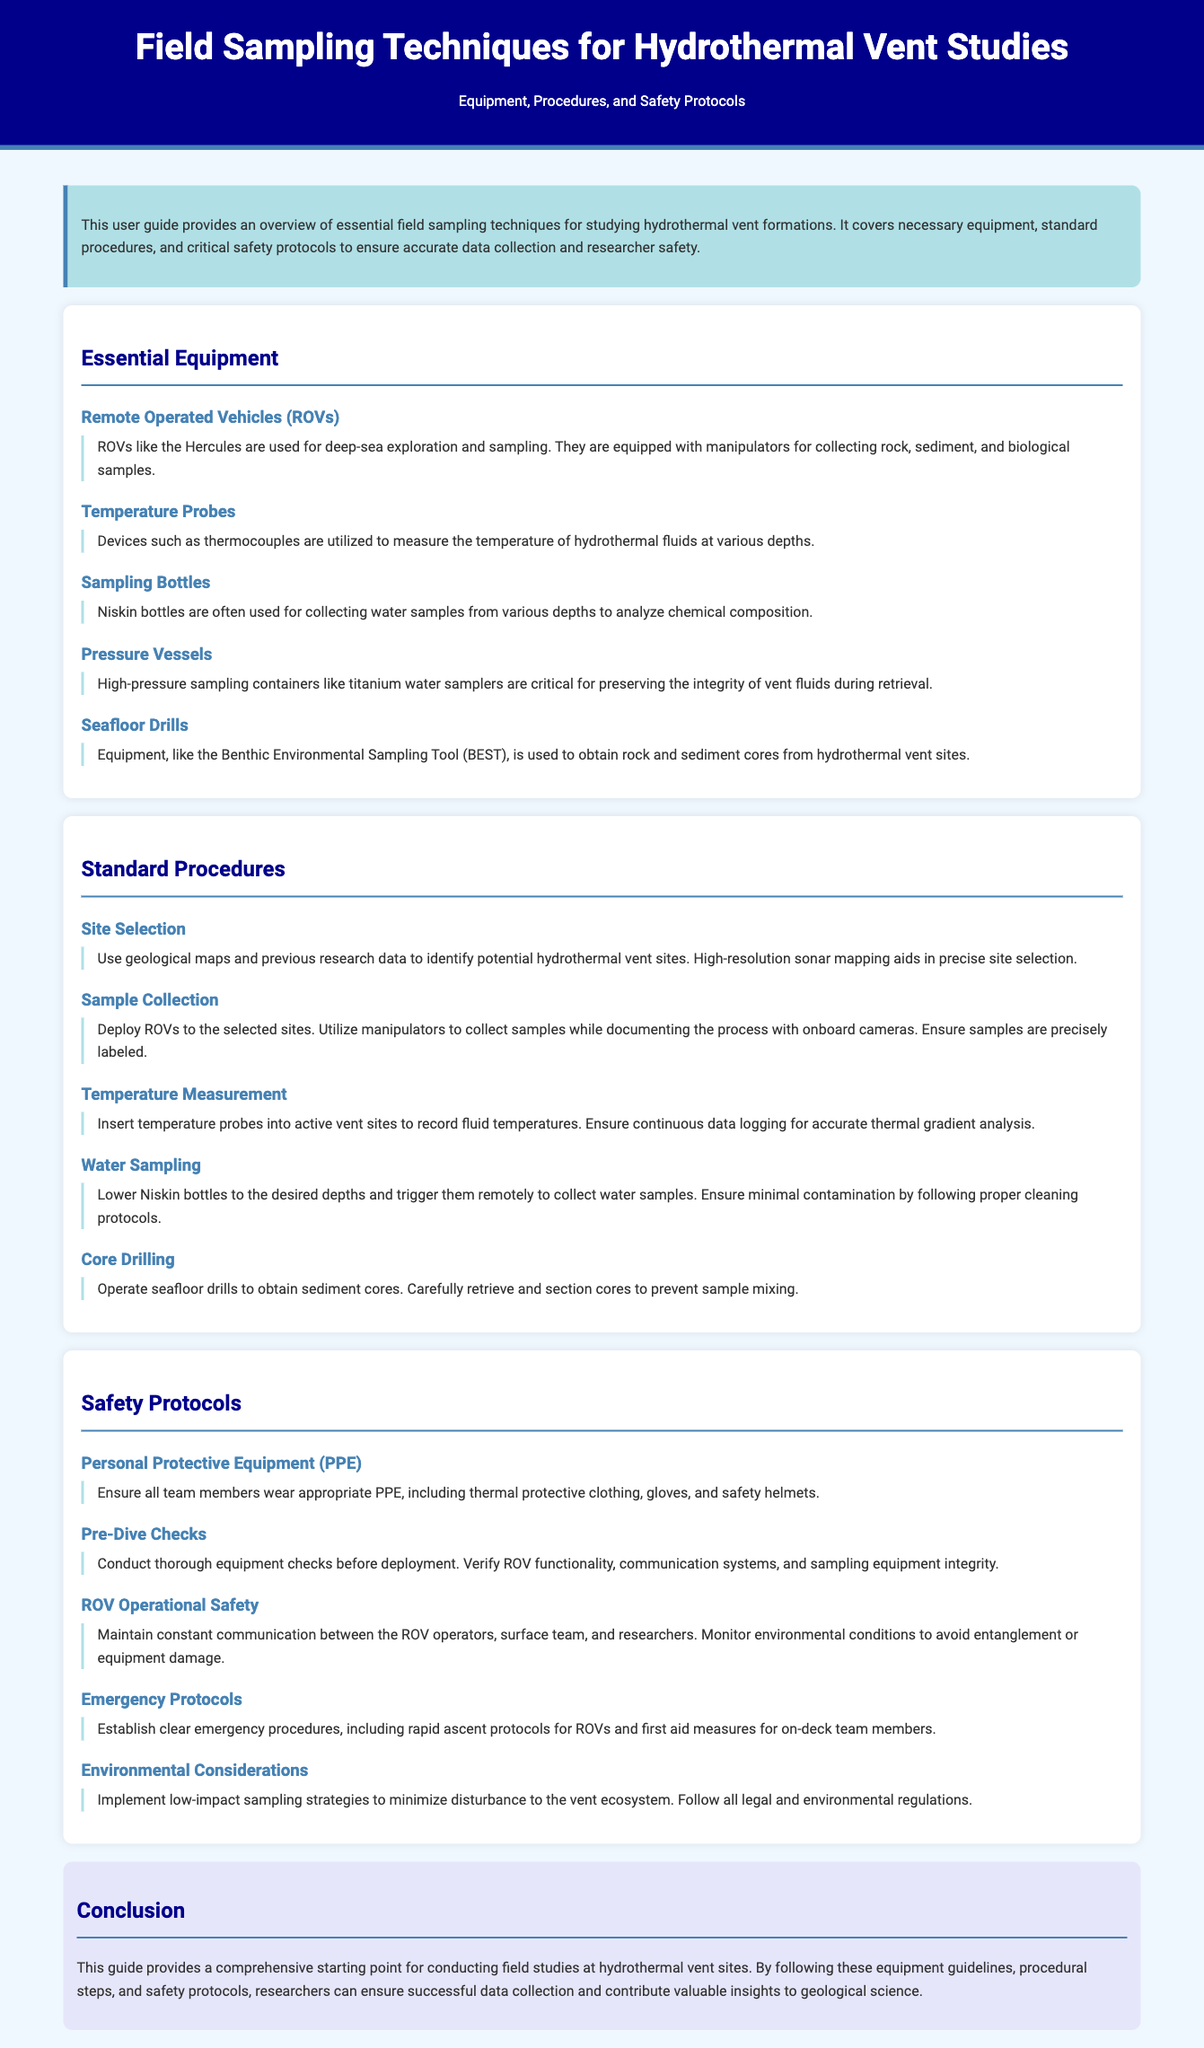what is the title of this user guide? The title is stated at the beginning of the document, indicating its focus on field sampling techniques for hydrothermal vent studies.
Answer: Field Sampling Techniques for Hydrothermal Vent Studies which equipment is used for deep-sea exploration? This is mentioned under the "Essential Equipment" section, specifying an ROV capable of deep-sea exploration.
Answer: ROVs what kind of samples do Niskin bottles collect? The document specifies that Niskin bottles are used for collecting water samples for chemical analysis.
Answer: Water samples how should temperature probes be used in the field? The "Temperature Measurement" section details the procedure for inserting probes into active vent sites for data collection.
Answer: Insert into active vent sites what is a critical safety protocol for ROV operation? The document outlines the importance of maintaining communication during ROV operations, which is critical for safety.
Answer: Constant communication how can researchers minimize their impact on the vent ecosystem? The guide emphasizes implementing low-impact sampling strategies as part of environmental considerations in safety protocols.
Answer: Low-impact sampling strategies what type of protective clothing is recommended for team members? The section on Personal Protective Equipment specifies the need for thermal protective clothing among other gear for safety.
Answer: Thermal protective clothing what tool is used for obtaining sediment cores? The document mentions a specific piece of equipment used for core drilling in sediment sampling.
Answer: Benthic Environmental Sampling Tool (BEST) 